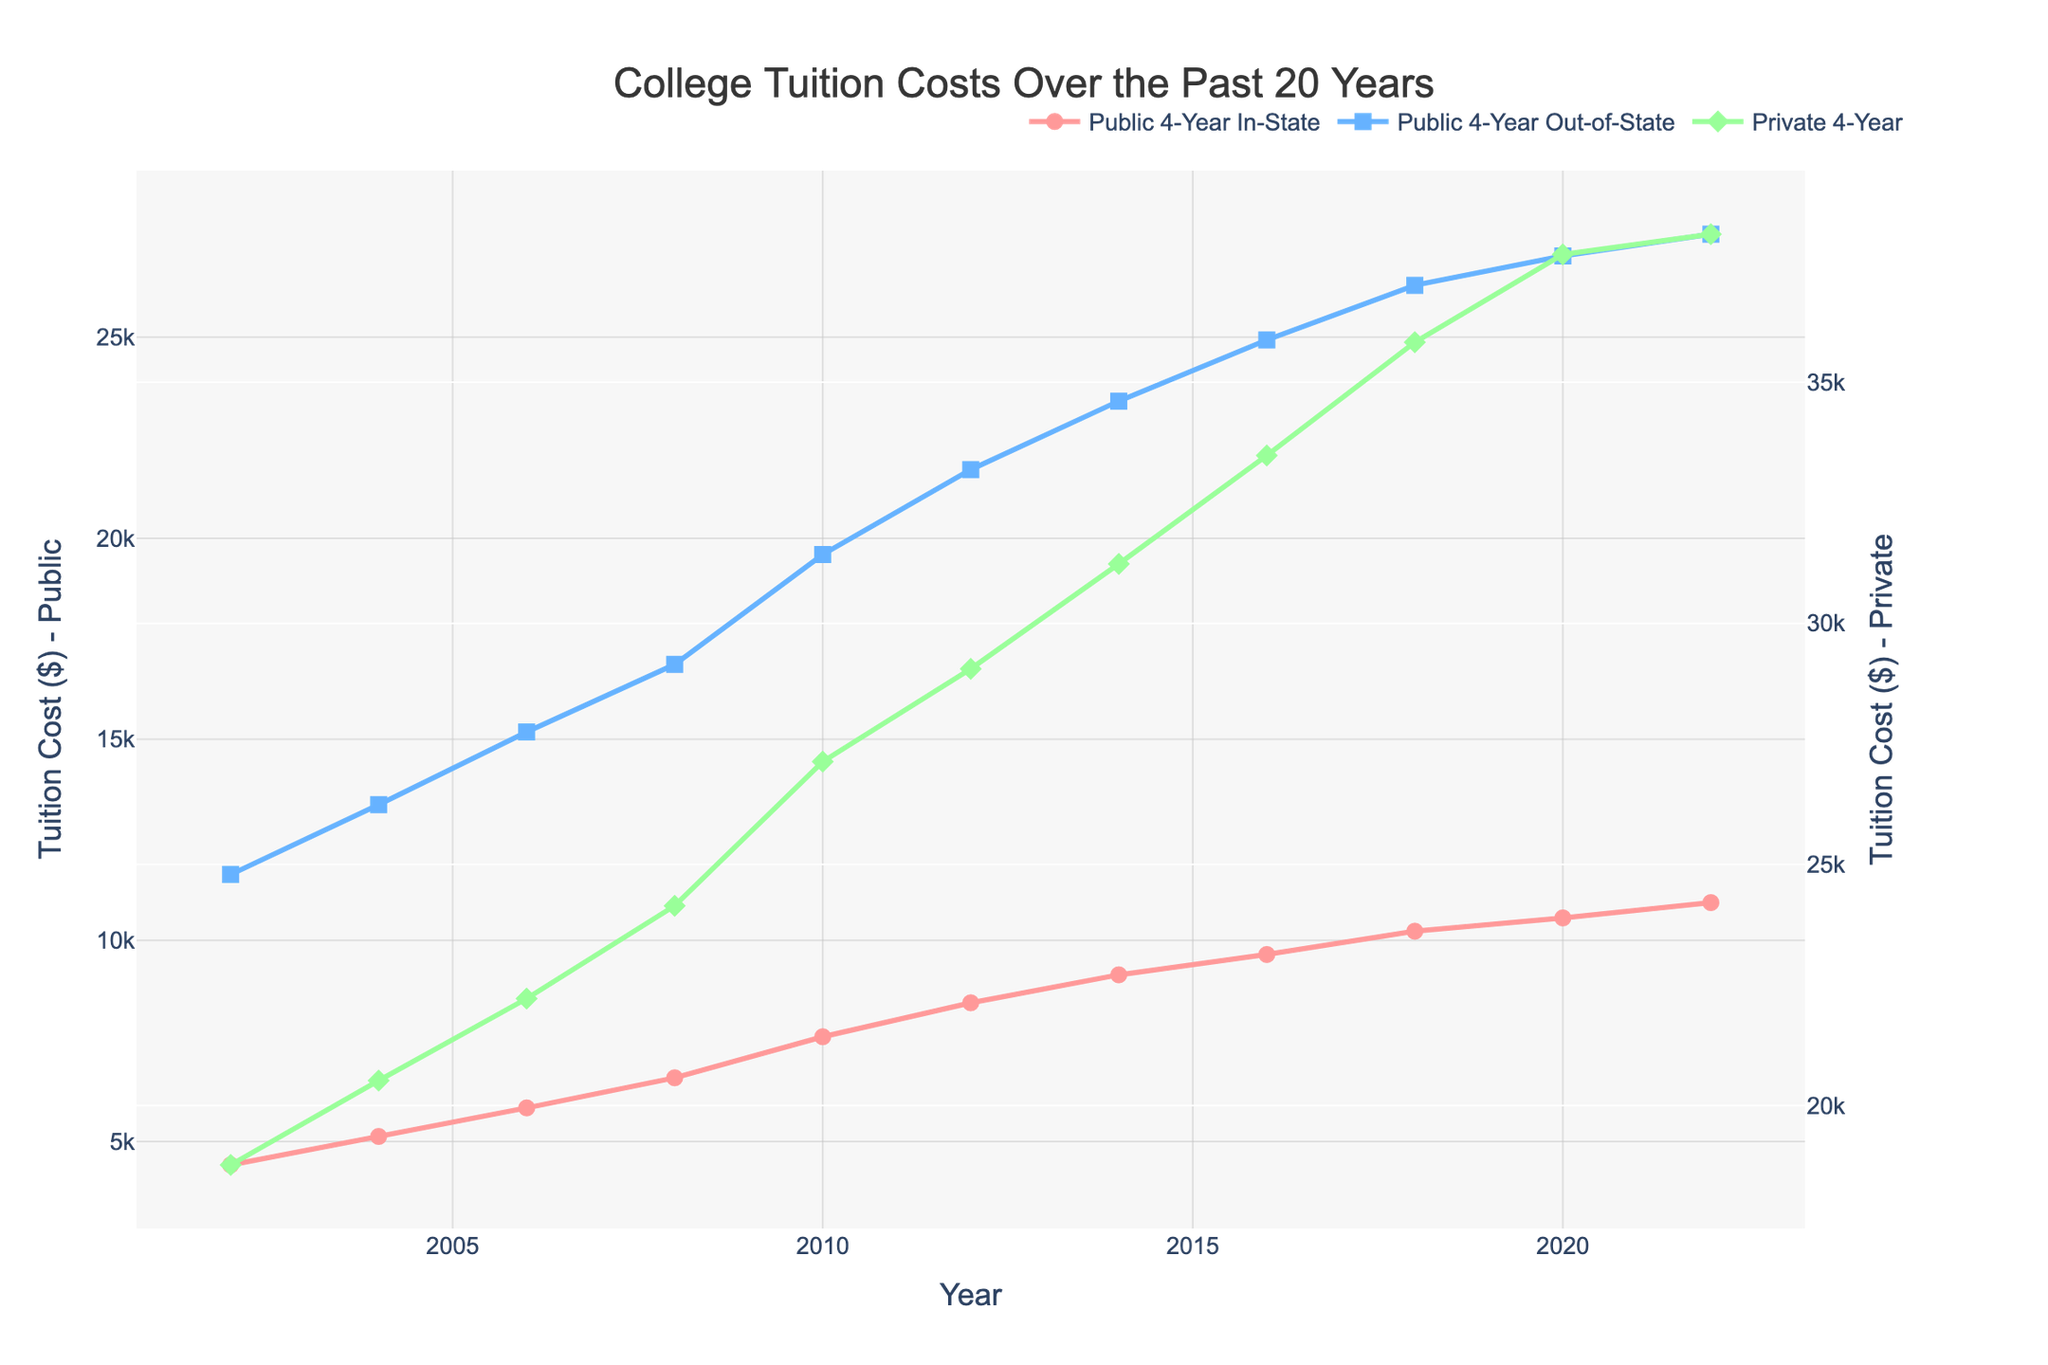What is the general trend for public in-state tuition costs from 2002 to 2022? The public in-state tuition costs have consistently increased over the years. Starting from $4,418 in 2002 and rising to $10,940 in 2022. Each data point is higher than the previous year's data point, indicating a consistent upward trend.
Answer: Upward trend Which year saw a significant rise in the private 4-year tuition costs compared to its previous year? A significant rise can be noted between 2010 and 2012 where the tuition costs increased from $27,131 to $29,056, this is an increase of $1,925.
Answer: 2012 How does the cost of public in-state tuitions in 2022 compare to 2002? Comparing the public 4-year in-state tuitions, in 2002 the cost was $4,418, and in 2022, it was $10,940. The difference is $10,940 - $4,418.
Answer: $6,522 In which year did the out-of-state public 4-year tuition cost exceed $20,000 for the first time? Reviewing the data points for public 4-year out-of-state tuition costs, the tuition cost first exceeded $20,000 in 2010 where it was $19,595 in 2008 and rose to $21,706 in 2012.
Answer: 2012 What is the difference in the rate of increase between public in-state and private 4-year tuition costs from 2002 to 2022? First, calculate the total increase for public in-state tuition: $10,940 (2022) - $4,418 (2002) = $6,522. For private 4-year: $38,070 (2022) - $18,768 (2002) = $19,302. So the difference in rate of increase is $19,302 - $6,522.
Answer: $12,780 During which period did the private 4-year tuition costs see the smallest increase compared to its previous value? Comparing the differences between consecutive years, the smallest increase is seen between 2020 and 2022 where the increase is only $420 ($38,070 - $37,650).
Answer: 2020-2022 Which category saw the highest increase in absolute dollars over the 20 years? Public 4-year out-of-state: $27,560 - $11,638 = $15,922; Public 4-year in-state: $10,940 - $4,418 = $6,522; Private 4-year: $38,070 - $18,768 = $19,302. Therefore, the private 4-year tuition had the highest increase.
Answer: Private 4-year What was the approximate average cost of private 4-year tuition fees over the 20 years? Sum of private tuition costs divided by the number of years. ($18,768 + $20,517 + $22,218 + $24,143 + $27,131 + $29,056 + $31,231 + $33,480 + $35,830 + $37,650 + $38,070) / 11 = $28,347.73.
Answer: $28,348 